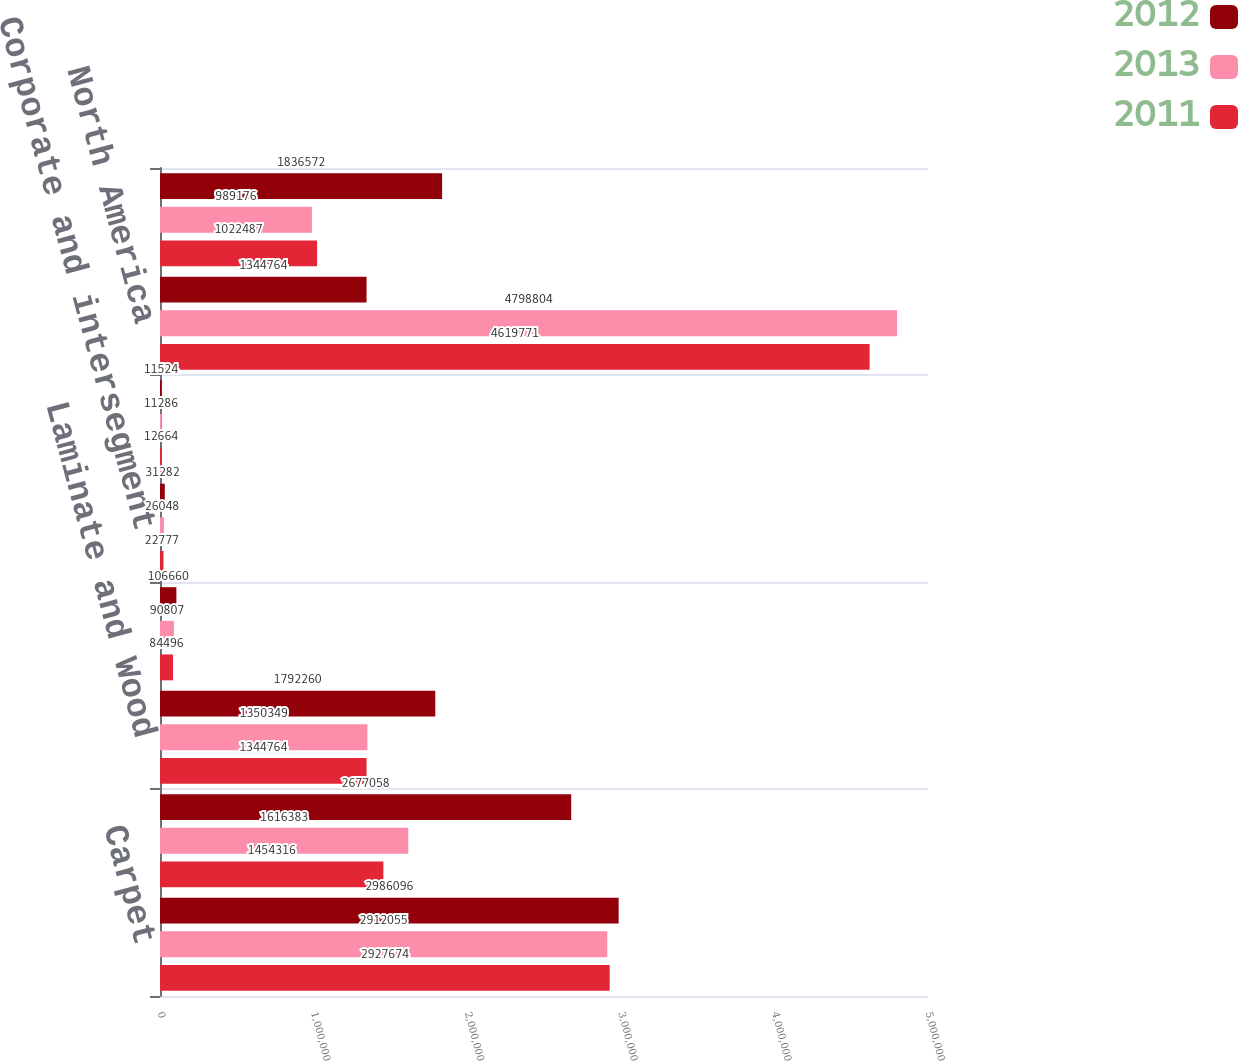Convert chart. <chart><loc_0><loc_0><loc_500><loc_500><stacked_bar_chart><ecel><fcel>Carpet<fcel>Ceramic<fcel>Laminate and Wood<fcel>Intersegment sales<fcel>Corporate and intersegment<fcel>Corporate<fcel>North America<fcel>Rest of world<nl><fcel>2012<fcel>2.9861e+06<fcel>2.67706e+06<fcel>1.79226e+06<fcel>106660<fcel>31282<fcel>11524<fcel>1.34476e+06<fcel>1.83657e+06<nl><fcel>2013<fcel>2.91206e+06<fcel>1.61638e+06<fcel>1.35035e+06<fcel>90807<fcel>26048<fcel>11286<fcel>4.7988e+06<fcel>989176<nl><fcel>2011<fcel>2.92767e+06<fcel>1.45432e+06<fcel>1.34476e+06<fcel>84496<fcel>22777<fcel>12664<fcel>4.61977e+06<fcel>1.02249e+06<nl></chart> 